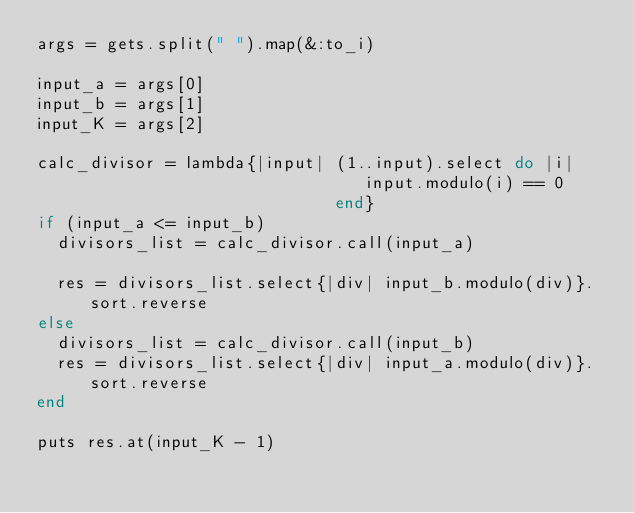Convert code to text. <code><loc_0><loc_0><loc_500><loc_500><_Ruby_>args = gets.split(" ").map(&:to_i)

input_a = args[0]
input_b = args[1]
input_K = args[2]

calc_divisor = lambda{|input| (1..input).select do |i|
                                 input.modulo(i) == 0
                              end}
if (input_a <= input_b)
  divisors_list = calc_divisor.call(input_a)
  
  res = divisors_list.select{|div| input_b.modulo(div)}.sort.reverse
else
  divisors_list = calc_divisor.call(input_b)
  res = divisors_list.select{|div| input_a.modulo(div)}.sort.reverse
end

puts res.at(input_K - 1)</code> 